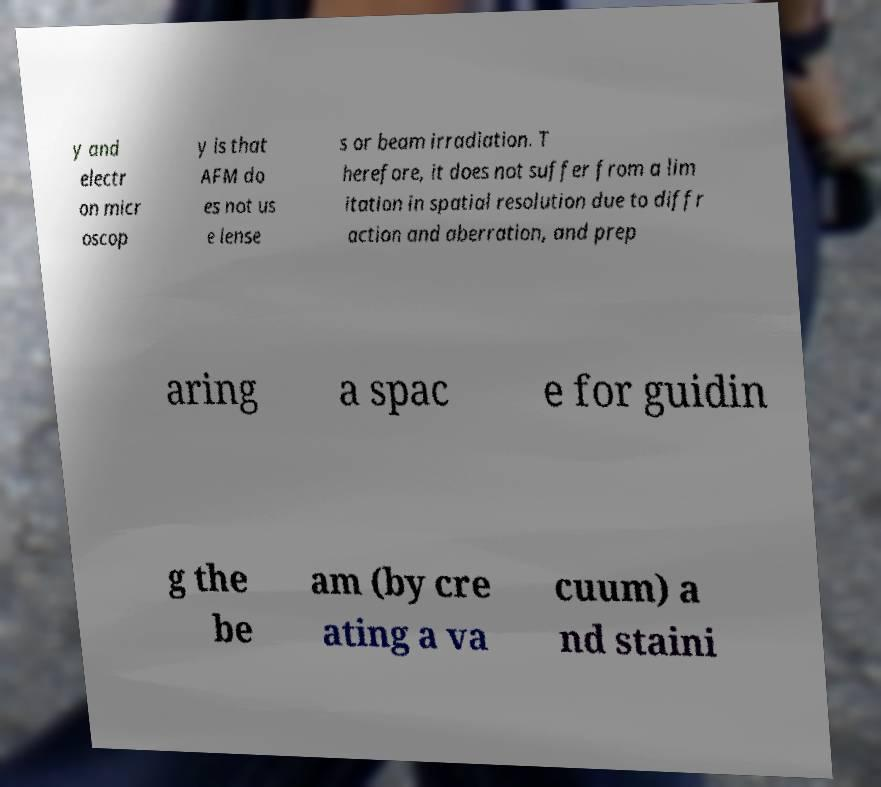I need the written content from this picture converted into text. Can you do that? y and electr on micr oscop y is that AFM do es not us e lense s or beam irradiation. T herefore, it does not suffer from a lim itation in spatial resolution due to diffr action and aberration, and prep aring a spac e for guidin g the be am (by cre ating a va cuum) a nd staini 